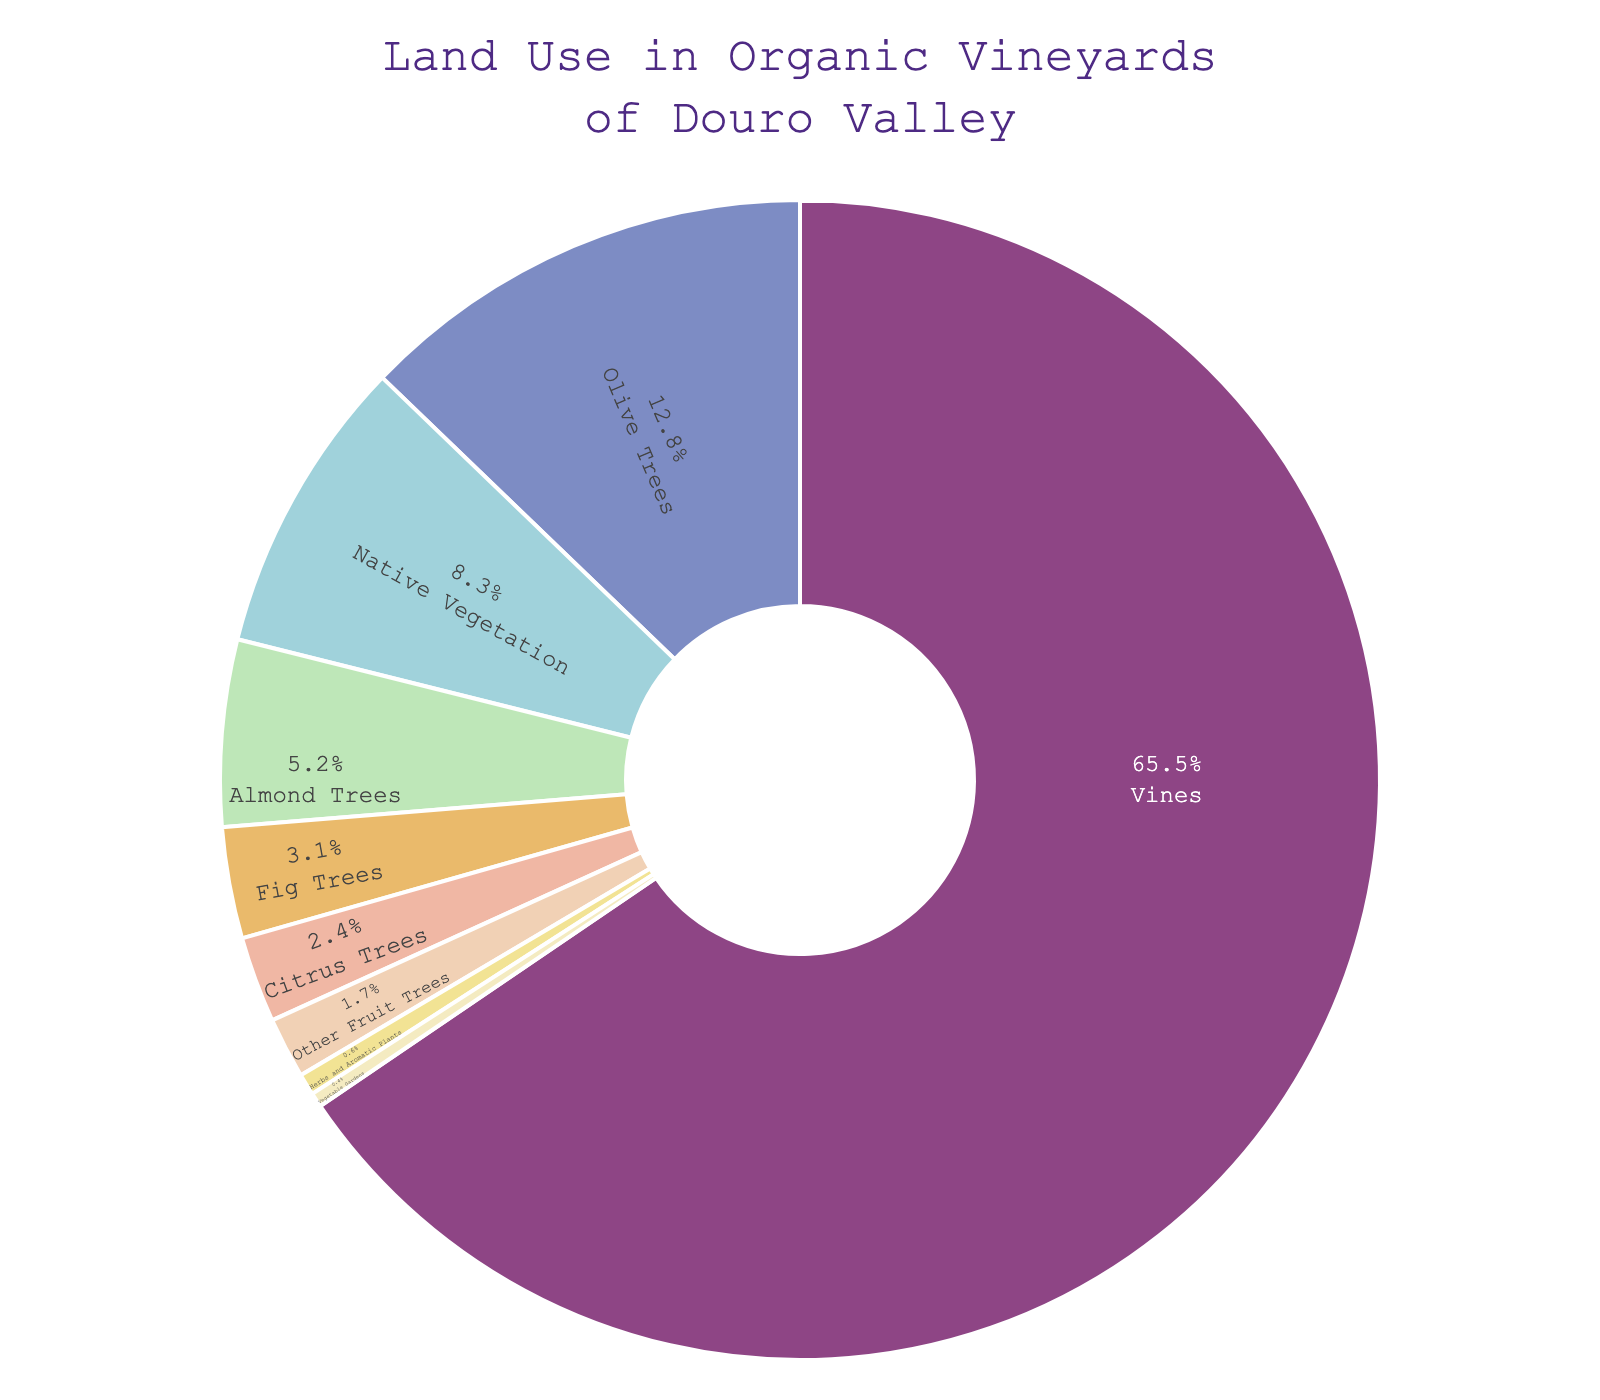What percentage of land is allocated to crops other than vines and olive trees? To find the percentage of land allocated to crops other than vines and olive trees, sum the percentages of all other categories: Native Vegetation (8.3) + Almond Trees (5.2) + Fig Trees (3.1) + Citrus Trees (2.4) + Other Fruit Trees (1.7) + Herbs and Aromatic Plants (0.6) + Vegetable Gardens (0.4) = 21.7%
Answer: 21.7% Which land use category occupies the smallest percentage of land? The land use category with the smallest percentage of land is the one with the lowest number in the data. Here, Vegetable Gardens have the smallest percentage of land use at 0.4%.
Answer: Vegetable Gardens How much more land is used for vines compared to olive trees? To find out how much more land is used for vines compared to olive trees, subtract the percentage of land used for olive trees from that used for vines: 65.5% - 12.8% = 52.7%
Answer: 52.7% Which categories collectively make up less than 10% of the total land use? To find the categories that collectively make up less than 10%, add their percentages until the sum is less than 10%. Starting with the smallest: Vegetable Gardens (0.4) + Herbs and Aromatic Plants (0.6) + Other Fruit Trees (1.7) + Citrus Trees (2.4) + Fig Trees (3.1) totals 8.2%. Thus, these categories collectively make up less than 10%.
Answer: Vegetable Gardens, Herbs and Aromatic Plants, Other Fruit Trees, Citrus Trees, Fig Trees Is the percentage of land use for native vegetation greater than the combined land use for herbs, other fruit trees, and citrus trees? First, sum the percentages of herbs, other fruit trees, and citrus trees: Herbs and Aromatic Plants (0.6) + Other Fruit Trees (1.7) + Citrus Trees (2.4) = 4.7%. Native Vegetation is 8.3%, which is greater than 4.7%.
Answer: Yes What is the difference in land use percentage between the largest and smallest categories? The largest category is vines at 65.5%, and the smallest is Vegetable Gardens at 0.4%. The difference is calculated as 65.5% - 0.4% = 65.1%.
Answer: 65.1% What percentage of the land is used for tree crops other than olive and almond trees? To find this, sum the percentages of tree crops other than olive and almond trees: Fig Trees (3.1) + Citrus Trees (2.4) + Other Fruit Trees (1.7) = 7.2%.
Answer: 7.2% Are olive trees the second most common land use category? By comparing the percentages, olive trees have a land use of 12.8%, which is the second highest after vines at 65.5%.
Answer: Yes 